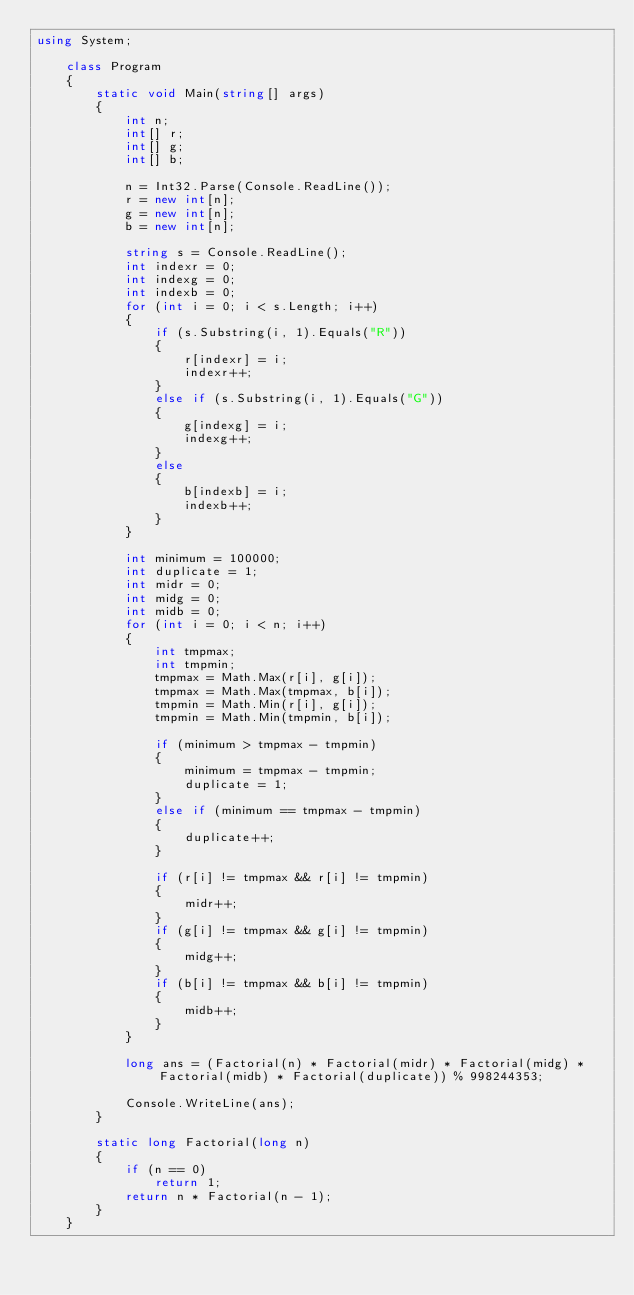Convert code to text. <code><loc_0><loc_0><loc_500><loc_500><_C#_>using System;

    class Program
    {
        static void Main(string[] args)
        {
            int n;
            int[] r;
            int[] g;
            int[] b;

            n = Int32.Parse(Console.ReadLine());
            r = new int[n];
            g = new int[n];
            b = new int[n];

            string s = Console.ReadLine();
            int indexr = 0;
            int indexg = 0;
            int indexb = 0;
            for (int i = 0; i < s.Length; i++)
            {
                if (s.Substring(i, 1).Equals("R"))
                {
                    r[indexr] = i;
                    indexr++;
                }
                else if (s.Substring(i, 1).Equals("G"))
                {
                    g[indexg] = i;
                    indexg++;
                }
                else
                {
                    b[indexb] = i;
                    indexb++;
                }
            }

            int minimum = 100000;
            int duplicate = 1;
            int midr = 0;
            int midg = 0;
            int midb = 0;
            for (int i = 0; i < n; i++)
            {
                int tmpmax;
                int tmpmin;
                tmpmax = Math.Max(r[i], g[i]);
                tmpmax = Math.Max(tmpmax, b[i]);
                tmpmin = Math.Min(r[i], g[i]);
                tmpmin = Math.Min(tmpmin, b[i]);

                if (minimum > tmpmax - tmpmin)
                {
                    minimum = tmpmax - tmpmin;
                    duplicate = 1;
                }
                else if (minimum == tmpmax - tmpmin)
                {
                    duplicate++;
                }

                if (r[i] != tmpmax && r[i] != tmpmin)
                {
                    midr++;
                }
                if (g[i] != tmpmax && g[i] != tmpmin)
                {
                    midg++;
                }
                if (b[i] != tmpmax && b[i] != tmpmin)
                {
                    midb++;
                }
            }

            long ans = (Factorial(n) * Factorial(midr) * Factorial(midg) * Factorial(midb) * Factorial(duplicate)) % 998244353;

            Console.WriteLine(ans);
        }

        static long Factorial(long n)
        {
            if (n == 0)
                return 1;
            return n * Factorial(n - 1);
        }
    }
</code> 